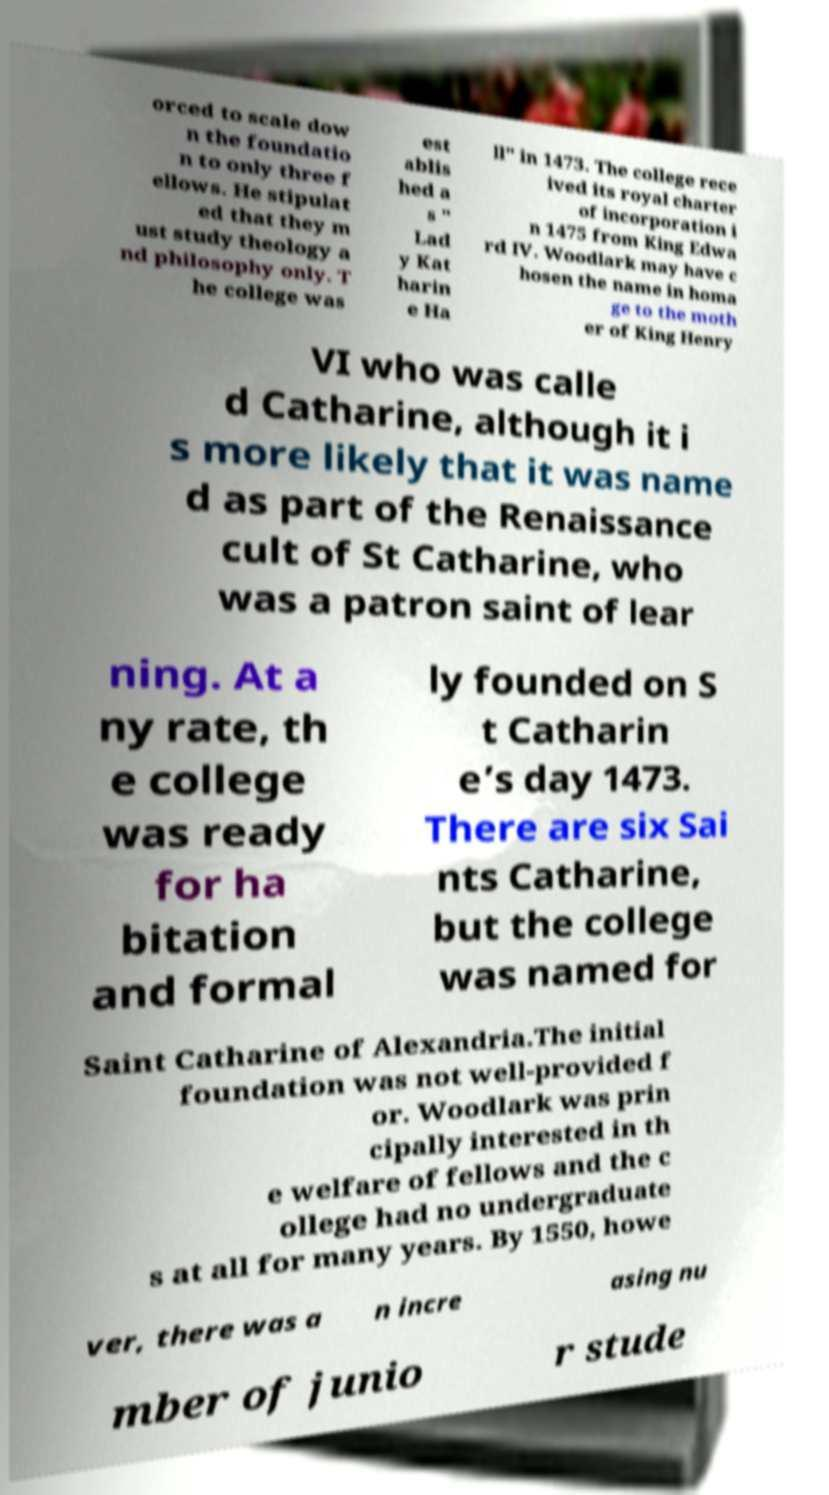Could you extract and type out the text from this image? orced to scale dow n the foundatio n to only three f ellows. He stipulat ed that they m ust study theology a nd philosophy only. T he college was est ablis hed a s " Lad y Kat harin e Ha ll" in 1473. The college rece ived its royal charter of incorporation i n 1475 from King Edwa rd IV. Woodlark may have c hosen the name in homa ge to the moth er of King Henry VI who was calle d Catharine, although it i s more likely that it was name d as part of the Renaissance cult of St Catharine, who was a patron saint of lear ning. At a ny rate, th e college was ready for ha bitation and formal ly founded on S t Catharin e’s day 1473. There are six Sai nts Catharine, but the college was named for Saint Catharine of Alexandria.The initial foundation was not well-provided f or. Woodlark was prin cipally interested in th e welfare of fellows and the c ollege had no undergraduate s at all for many years. By 1550, howe ver, there was a n incre asing nu mber of junio r stude 